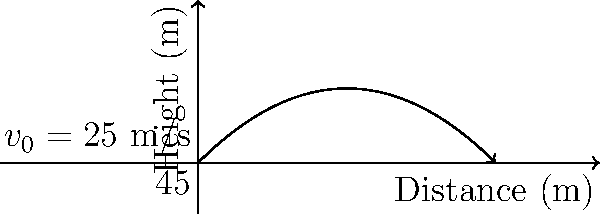As a marathon runner, you're attending a track and field event to support your athlete friends. You observe a javelin throw and decide to calculate its trajectory. Given an initial velocity of 25 m/s and a launch angle of 45°, what is the maximum height reached by the javelin? (Assume g = 9.8 m/s²) Let's approach this step-by-step:

1) The trajectory of a projectile (like a javelin) follows a parabolic path. The maximum height occurs at the vertex of this parabola.

2) To find the maximum height, we need to use the equation:

   $$h_{max} = \frac{v_0^2 \sin^2 \theta}{2g}$$

   Where:
   $h_{max}$ is the maximum height
   $v_0$ is the initial velocity
   $\theta$ is the launch angle
   $g$ is the acceleration due to gravity

3) We're given:
   $v_0 = 25$ m/s
   $\theta = 45°$
   $g = 9.8$ m/s²

4) First, let's calculate $\sin^2 \theta$:
   $\sin 45° = \frac{1}{\sqrt{2}} \approx 0.7071$
   $\sin^2 45° \approx 0.5$

5) Now, let's substitute these values into our equation:

   $$h_{max} = \frac{25^2 \times 0.5}{2 \times 9.8}$$

6) Simplify:
   $$h_{max} = \frac{625 \times 0.5}{19.6} = \frac{312.5}{19.6}$$

7) Calculate:
   $$h_{max} \approx 15.94$$ meters

Therefore, the maximum height reached by the javelin is approximately 15.94 meters.
Answer: 15.94 meters 